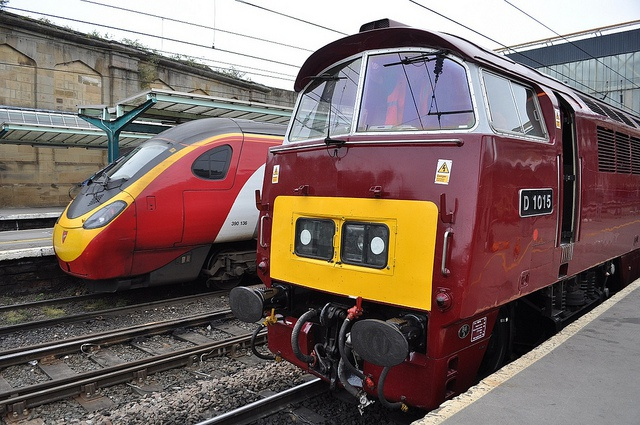Describe the objects in this image and their specific colors. I can see train in darkgray, black, maroon, and gray tones, train in darkgray, brown, black, and maroon tones, and people in darkgray and gray tones in this image. 